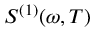<formula> <loc_0><loc_0><loc_500><loc_500>S ^ { ( 1 ) } ( \omega , T )</formula> 